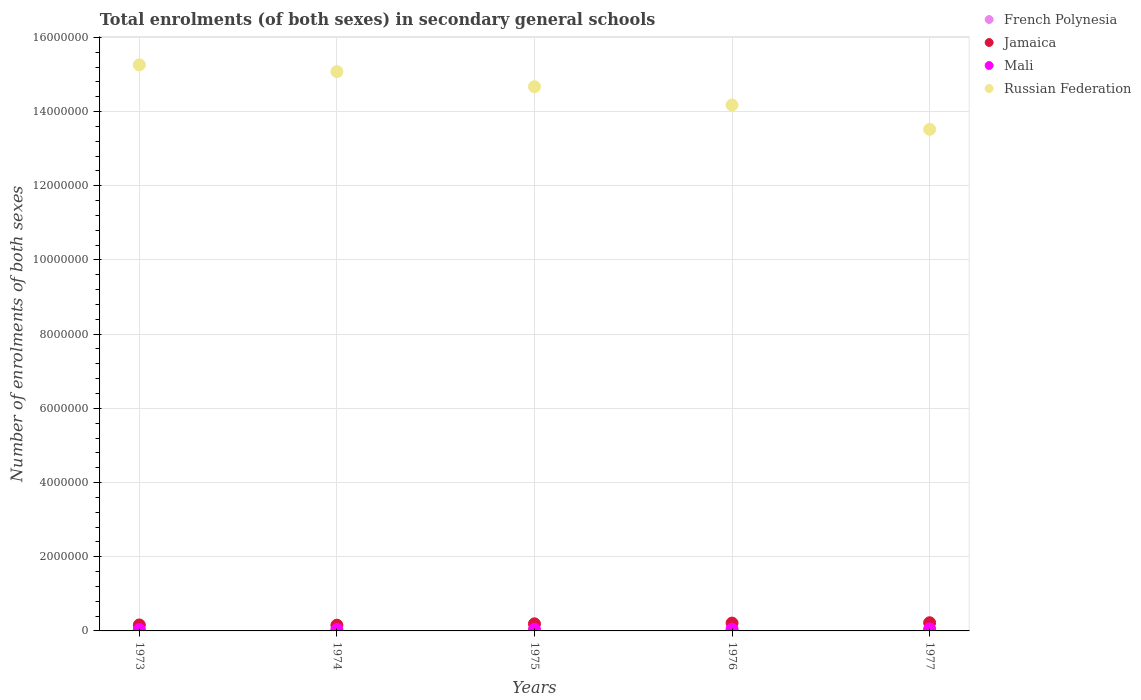What is the number of enrolments in secondary schools in Jamaica in 1976?
Ensure brevity in your answer.  2.11e+05. Across all years, what is the maximum number of enrolments in secondary schools in Mali?
Make the answer very short. 5.55e+04. Across all years, what is the minimum number of enrolments in secondary schools in Russian Federation?
Make the answer very short. 1.35e+07. What is the total number of enrolments in secondary schools in French Polynesia in the graph?
Your response must be concise. 3.49e+04. What is the difference between the number of enrolments in secondary schools in Russian Federation in 1973 and that in 1977?
Provide a succinct answer. 1.74e+06. What is the difference between the number of enrolments in secondary schools in Jamaica in 1974 and the number of enrolments in secondary schools in Russian Federation in 1977?
Your answer should be very brief. -1.34e+07. What is the average number of enrolments in secondary schools in Mali per year?
Ensure brevity in your answer.  4.39e+04. In the year 1973, what is the difference between the number of enrolments in secondary schools in Russian Federation and number of enrolments in secondary schools in French Polynesia?
Ensure brevity in your answer.  1.53e+07. In how many years, is the number of enrolments in secondary schools in French Polynesia greater than 1600000?
Give a very brief answer. 0. What is the ratio of the number of enrolments in secondary schools in French Polynesia in 1974 to that in 1976?
Your answer should be very brief. 0.91. Is the number of enrolments in secondary schools in Mali in 1973 less than that in 1976?
Your answer should be very brief. Yes. What is the difference between the highest and the second highest number of enrolments in secondary schools in Jamaica?
Your response must be concise. 9257. What is the difference between the highest and the lowest number of enrolments in secondary schools in Russian Federation?
Your answer should be very brief. 1.74e+06. In how many years, is the number of enrolments in secondary schools in Russian Federation greater than the average number of enrolments in secondary schools in Russian Federation taken over all years?
Give a very brief answer. 3. Is it the case that in every year, the sum of the number of enrolments in secondary schools in Russian Federation and number of enrolments in secondary schools in Mali  is greater than the sum of number of enrolments in secondary schools in Jamaica and number of enrolments in secondary schools in French Polynesia?
Offer a terse response. Yes. Is the number of enrolments in secondary schools in Mali strictly greater than the number of enrolments in secondary schools in Jamaica over the years?
Provide a succinct answer. No. How many dotlines are there?
Your answer should be very brief. 4. Are the values on the major ticks of Y-axis written in scientific E-notation?
Give a very brief answer. No. Does the graph contain any zero values?
Provide a succinct answer. No. What is the title of the graph?
Your response must be concise. Total enrolments (of both sexes) in secondary general schools. What is the label or title of the X-axis?
Offer a very short reply. Years. What is the label or title of the Y-axis?
Give a very brief answer. Number of enrolments of both sexes. What is the Number of enrolments of both sexes of French Polynesia in 1973?
Your answer should be very brief. 6239. What is the Number of enrolments of both sexes of Jamaica in 1973?
Offer a very short reply. 1.61e+05. What is the Number of enrolments of both sexes of Mali in 1973?
Offer a terse response. 3.46e+04. What is the Number of enrolments of both sexes in Russian Federation in 1973?
Offer a very short reply. 1.53e+07. What is the Number of enrolments of both sexes in French Polynesia in 1974?
Your answer should be very brief. 6597. What is the Number of enrolments of both sexes of Jamaica in 1974?
Ensure brevity in your answer.  1.55e+05. What is the Number of enrolments of both sexes of Mali in 1974?
Your response must be concise. 3.80e+04. What is the Number of enrolments of both sexes in Russian Federation in 1974?
Make the answer very short. 1.51e+07. What is the Number of enrolments of both sexes of French Polynesia in 1975?
Your answer should be very brief. 7046. What is the Number of enrolments of both sexes of Jamaica in 1975?
Give a very brief answer. 1.92e+05. What is the Number of enrolments of both sexes in Mali in 1975?
Make the answer very short. 4.27e+04. What is the Number of enrolments of both sexes in Russian Federation in 1975?
Keep it short and to the point. 1.47e+07. What is the Number of enrolments of both sexes in French Polynesia in 1976?
Make the answer very short. 7280. What is the Number of enrolments of both sexes of Jamaica in 1976?
Offer a very short reply. 2.11e+05. What is the Number of enrolments of both sexes of Mali in 1976?
Offer a terse response. 4.85e+04. What is the Number of enrolments of both sexes of Russian Federation in 1976?
Keep it short and to the point. 1.42e+07. What is the Number of enrolments of both sexes of French Polynesia in 1977?
Provide a succinct answer. 7727. What is the Number of enrolments of both sexes of Jamaica in 1977?
Offer a terse response. 2.21e+05. What is the Number of enrolments of both sexes in Mali in 1977?
Ensure brevity in your answer.  5.55e+04. What is the Number of enrolments of both sexes of Russian Federation in 1977?
Your response must be concise. 1.35e+07. Across all years, what is the maximum Number of enrolments of both sexes of French Polynesia?
Ensure brevity in your answer.  7727. Across all years, what is the maximum Number of enrolments of both sexes of Jamaica?
Your response must be concise. 2.21e+05. Across all years, what is the maximum Number of enrolments of both sexes of Mali?
Offer a very short reply. 5.55e+04. Across all years, what is the maximum Number of enrolments of both sexes of Russian Federation?
Ensure brevity in your answer.  1.53e+07. Across all years, what is the minimum Number of enrolments of both sexes of French Polynesia?
Provide a short and direct response. 6239. Across all years, what is the minimum Number of enrolments of both sexes of Jamaica?
Your answer should be compact. 1.55e+05. Across all years, what is the minimum Number of enrolments of both sexes in Mali?
Your answer should be compact. 3.46e+04. Across all years, what is the minimum Number of enrolments of both sexes of Russian Federation?
Your answer should be very brief. 1.35e+07. What is the total Number of enrolments of both sexes in French Polynesia in the graph?
Give a very brief answer. 3.49e+04. What is the total Number of enrolments of both sexes in Jamaica in the graph?
Offer a terse response. 9.39e+05. What is the total Number of enrolments of both sexes in Mali in the graph?
Offer a terse response. 2.19e+05. What is the total Number of enrolments of both sexes in Russian Federation in the graph?
Ensure brevity in your answer.  7.27e+07. What is the difference between the Number of enrolments of both sexes of French Polynesia in 1973 and that in 1974?
Provide a succinct answer. -358. What is the difference between the Number of enrolments of both sexes of Jamaica in 1973 and that in 1974?
Ensure brevity in your answer.  6427. What is the difference between the Number of enrolments of both sexes of Mali in 1973 and that in 1974?
Your response must be concise. -3370. What is the difference between the Number of enrolments of both sexes in Russian Federation in 1973 and that in 1974?
Your answer should be very brief. 1.83e+05. What is the difference between the Number of enrolments of both sexes of French Polynesia in 1973 and that in 1975?
Give a very brief answer. -807. What is the difference between the Number of enrolments of both sexes in Jamaica in 1973 and that in 1975?
Provide a short and direct response. -3.09e+04. What is the difference between the Number of enrolments of both sexes in Mali in 1973 and that in 1975?
Your response must be concise. -8040. What is the difference between the Number of enrolments of both sexes in Russian Federation in 1973 and that in 1975?
Offer a very short reply. 5.89e+05. What is the difference between the Number of enrolments of both sexes of French Polynesia in 1973 and that in 1976?
Your answer should be very brief. -1041. What is the difference between the Number of enrolments of both sexes of Jamaica in 1973 and that in 1976?
Your response must be concise. -5.03e+04. What is the difference between the Number of enrolments of both sexes in Mali in 1973 and that in 1976?
Ensure brevity in your answer.  -1.39e+04. What is the difference between the Number of enrolments of both sexes of Russian Federation in 1973 and that in 1976?
Your response must be concise. 1.08e+06. What is the difference between the Number of enrolments of both sexes in French Polynesia in 1973 and that in 1977?
Your answer should be very brief. -1488. What is the difference between the Number of enrolments of both sexes in Jamaica in 1973 and that in 1977?
Keep it short and to the point. -5.96e+04. What is the difference between the Number of enrolments of both sexes of Mali in 1973 and that in 1977?
Offer a very short reply. -2.09e+04. What is the difference between the Number of enrolments of both sexes of Russian Federation in 1973 and that in 1977?
Keep it short and to the point. 1.74e+06. What is the difference between the Number of enrolments of both sexes of French Polynesia in 1974 and that in 1975?
Provide a succinct answer. -449. What is the difference between the Number of enrolments of both sexes in Jamaica in 1974 and that in 1975?
Give a very brief answer. -3.73e+04. What is the difference between the Number of enrolments of both sexes in Mali in 1974 and that in 1975?
Keep it short and to the point. -4670. What is the difference between the Number of enrolments of both sexes of Russian Federation in 1974 and that in 1975?
Give a very brief answer. 4.06e+05. What is the difference between the Number of enrolments of both sexes in French Polynesia in 1974 and that in 1976?
Your answer should be compact. -683. What is the difference between the Number of enrolments of both sexes of Jamaica in 1974 and that in 1976?
Your answer should be compact. -5.68e+04. What is the difference between the Number of enrolments of both sexes of Mali in 1974 and that in 1976?
Make the answer very short. -1.05e+04. What is the difference between the Number of enrolments of both sexes of Russian Federation in 1974 and that in 1976?
Your answer should be very brief. 8.99e+05. What is the difference between the Number of enrolments of both sexes of French Polynesia in 1974 and that in 1977?
Give a very brief answer. -1130. What is the difference between the Number of enrolments of both sexes of Jamaica in 1974 and that in 1977?
Offer a very short reply. -6.60e+04. What is the difference between the Number of enrolments of both sexes in Mali in 1974 and that in 1977?
Give a very brief answer. -1.75e+04. What is the difference between the Number of enrolments of both sexes of Russian Federation in 1974 and that in 1977?
Make the answer very short. 1.56e+06. What is the difference between the Number of enrolments of both sexes of French Polynesia in 1975 and that in 1976?
Keep it short and to the point. -234. What is the difference between the Number of enrolments of both sexes of Jamaica in 1975 and that in 1976?
Give a very brief answer. -1.94e+04. What is the difference between the Number of enrolments of both sexes of Mali in 1975 and that in 1976?
Your response must be concise. -5820. What is the difference between the Number of enrolments of both sexes in Russian Federation in 1975 and that in 1976?
Offer a very short reply. 4.93e+05. What is the difference between the Number of enrolments of both sexes in French Polynesia in 1975 and that in 1977?
Your response must be concise. -681. What is the difference between the Number of enrolments of both sexes in Jamaica in 1975 and that in 1977?
Your answer should be very brief. -2.87e+04. What is the difference between the Number of enrolments of both sexes in Mali in 1975 and that in 1977?
Offer a terse response. -1.28e+04. What is the difference between the Number of enrolments of both sexes in Russian Federation in 1975 and that in 1977?
Give a very brief answer. 1.15e+06. What is the difference between the Number of enrolments of both sexes of French Polynesia in 1976 and that in 1977?
Give a very brief answer. -447. What is the difference between the Number of enrolments of both sexes of Jamaica in 1976 and that in 1977?
Provide a short and direct response. -9257. What is the difference between the Number of enrolments of both sexes in Mali in 1976 and that in 1977?
Keep it short and to the point. -6997. What is the difference between the Number of enrolments of both sexes of Russian Federation in 1976 and that in 1977?
Your answer should be very brief. 6.56e+05. What is the difference between the Number of enrolments of both sexes in French Polynesia in 1973 and the Number of enrolments of both sexes in Jamaica in 1974?
Ensure brevity in your answer.  -1.48e+05. What is the difference between the Number of enrolments of both sexes in French Polynesia in 1973 and the Number of enrolments of both sexes in Mali in 1974?
Your answer should be compact. -3.18e+04. What is the difference between the Number of enrolments of both sexes in French Polynesia in 1973 and the Number of enrolments of both sexes in Russian Federation in 1974?
Give a very brief answer. -1.51e+07. What is the difference between the Number of enrolments of both sexes in Jamaica in 1973 and the Number of enrolments of both sexes in Mali in 1974?
Give a very brief answer. 1.23e+05. What is the difference between the Number of enrolments of both sexes in Jamaica in 1973 and the Number of enrolments of both sexes in Russian Federation in 1974?
Your response must be concise. -1.49e+07. What is the difference between the Number of enrolments of both sexes of Mali in 1973 and the Number of enrolments of both sexes of Russian Federation in 1974?
Your answer should be compact. -1.50e+07. What is the difference between the Number of enrolments of both sexes of French Polynesia in 1973 and the Number of enrolments of both sexes of Jamaica in 1975?
Provide a short and direct response. -1.86e+05. What is the difference between the Number of enrolments of both sexes in French Polynesia in 1973 and the Number of enrolments of both sexes in Mali in 1975?
Your answer should be compact. -3.64e+04. What is the difference between the Number of enrolments of both sexes of French Polynesia in 1973 and the Number of enrolments of both sexes of Russian Federation in 1975?
Give a very brief answer. -1.47e+07. What is the difference between the Number of enrolments of both sexes of Jamaica in 1973 and the Number of enrolments of both sexes of Mali in 1975?
Offer a very short reply. 1.18e+05. What is the difference between the Number of enrolments of both sexes in Jamaica in 1973 and the Number of enrolments of both sexes in Russian Federation in 1975?
Your answer should be very brief. -1.45e+07. What is the difference between the Number of enrolments of both sexes in Mali in 1973 and the Number of enrolments of both sexes in Russian Federation in 1975?
Your response must be concise. -1.46e+07. What is the difference between the Number of enrolments of both sexes in French Polynesia in 1973 and the Number of enrolments of both sexes in Jamaica in 1976?
Provide a succinct answer. -2.05e+05. What is the difference between the Number of enrolments of both sexes of French Polynesia in 1973 and the Number of enrolments of both sexes of Mali in 1976?
Your answer should be compact. -4.22e+04. What is the difference between the Number of enrolments of both sexes of French Polynesia in 1973 and the Number of enrolments of both sexes of Russian Federation in 1976?
Make the answer very short. -1.42e+07. What is the difference between the Number of enrolments of both sexes of Jamaica in 1973 and the Number of enrolments of both sexes of Mali in 1976?
Give a very brief answer. 1.12e+05. What is the difference between the Number of enrolments of both sexes of Jamaica in 1973 and the Number of enrolments of both sexes of Russian Federation in 1976?
Provide a short and direct response. -1.40e+07. What is the difference between the Number of enrolments of both sexes of Mali in 1973 and the Number of enrolments of both sexes of Russian Federation in 1976?
Your answer should be very brief. -1.41e+07. What is the difference between the Number of enrolments of both sexes of French Polynesia in 1973 and the Number of enrolments of both sexes of Jamaica in 1977?
Ensure brevity in your answer.  -2.14e+05. What is the difference between the Number of enrolments of both sexes in French Polynesia in 1973 and the Number of enrolments of both sexes in Mali in 1977?
Offer a terse response. -4.92e+04. What is the difference between the Number of enrolments of both sexes in French Polynesia in 1973 and the Number of enrolments of both sexes in Russian Federation in 1977?
Keep it short and to the point. -1.35e+07. What is the difference between the Number of enrolments of both sexes of Jamaica in 1973 and the Number of enrolments of both sexes of Mali in 1977?
Ensure brevity in your answer.  1.05e+05. What is the difference between the Number of enrolments of both sexes in Jamaica in 1973 and the Number of enrolments of both sexes in Russian Federation in 1977?
Make the answer very short. -1.34e+07. What is the difference between the Number of enrolments of both sexes of Mali in 1973 and the Number of enrolments of both sexes of Russian Federation in 1977?
Keep it short and to the point. -1.35e+07. What is the difference between the Number of enrolments of both sexes in French Polynesia in 1974 and the Number of enrolments of both sexes in Jamaica in 1975?
Your answer should be compact. -1.85e+05. What is the difference between the Number of enrolments of both sexes in French Polynesia in 1974 and the Number of enrolments of both sexes in Mali in 1975?
Give a very brief answer. -3.61e+04. What is the difference between the Number of enrolments of both sexes in French Polynesia in 1974 and the Number of enrolments of both sexes in Russian Federation in 1975?
Give a very brief answer. -1.47e+07. What is the difference between the Number of enrolments of both sexes of Jamaica in 1974 and the Number of enrolments of both sexes of Mali in 1975?
Your response must be concise. 1.12e+05. What is the difference between the Number of enrolments of both sexes in Jamaica in 1974 and the Number of enrolments of both sexes in Russian Federation in 1975?
Your answer should be compact. -1.45e+07. What is the difference between the Number of enrolments of both sexes of Mali in 1974 and the Number of enrolments of both sexes of Russian Federation in 1975?
Your answer should be very brief. -1.46e+07. What is the difference between the Number of enrolments of both sexes of French Polynesia in 1974 and the Number of enrolments of both sexes of Jamaica in 1976?
Provide a succinct answer. -2.05e+05. What is the difference between the Number of enrolments of both sexes in French Polynesia in 1974 and the Number of enrolments of both sexes in Mali in 1976?
Offer a terse response. -4.19e+04. What is the difference between the Number of enrolments of both sexes in French Polynesia in 1974 and the Number of enrolments of both sexes in Russian Federation in 1976?
Ensure brevity in your answer.  -1.42e+07. What is the difference between the Number of enrolments of both sexes in Jamaica in 1974 and the Number of enrolments of both sexes in Mali in 1976?
Offer a terse response. 1.06e+05. What is the difference between the Number of enrolments of both sexes of Jamaica in 1974 and the Number of enrolments of both sexes of Russian Federation in 1976?
Make the answer very short. -1.40e+07. What is the difference between the Number of enrolments of both sexes in Mali in 1974 and the Number of enrolments of both sexes in Russian Federation in 1976?
Your answer should be compact. -1.41e+07. What is the difference between the Number of enrolments of both sexes in French Polynesia in 1974 and the Number of enrolments of both sexes in Jamaica in 1977?
Give a very brief answer. -2.14e+05. What is the difference between the Number of enrolments of both sexes of French Polynesia in 1974 and the Number of enrolments of both sexes of Mali in 1977?
Make the answer very short. -4.89e+04. What is the difference between the Number of enrolments of both sexes in French Polynesia in 1974 and the Number of enrolments of both sexes in Russian Federation in 1977?
Provide a succinct answer. -1.35e+07. What is the difference between the Number of enrolments of both sexes of Jamaica in 1974 and the Number of enrolments of both sexes of Mali in 1977?
Make the answer very short. 9.91e+04. What is the difference between the Number of enrolments of both sexes in Jamaica in 1974 and the Number of enrolments of both sexes in Russian Federation in 1977?
Provide a succinct answer. -1.34e+07. What is the difference between the Number of enrolments of both sexes in Mali in 1974 and the Number of enrolments of both sexes in Russian Federation in 1977?
Offer a terse response. -1.35e+07. What is the difference between the Number of enrolments of both sexes in French Polynesia in 1975 and the Number of enrolments of both sexes in Jamaica in 1976?
Keep it short and to the point. -2.04e+05. What is the difference between the Number of enrolments of both sexes in French Polynesia in 1975 and the Number of enrolments of both sexes in Mali in 1976?
Your answer should be very brief. -4.14e+04. What is the difference between the Number of enrolments of both sexes in French Polynesia in 1975 and the Number of enrolments of both sexes in Russian Federation in 1976?
Your answer should be compact. -1.42e+07. What is the difference between the Number of enrolments of both sexes in Jamaica in 1975 and the Number of enrolments of both sexes in Mali in 1976?
Provide a succinct answer. 1.43e+05. What is the difference between the Number of enrolments of both sexes in Jamaica in 1975 and the Number of enrolments of both sexes in Russian Federation in 1976?
Offer a terse response. -1.40e+07. What is the difference between the Number of enrolments of both sexes of Mali in 1975 and the Number of enrolments of both sexes of Russian Federation in 1976?
Ensure brevity in your answer.  -1.41e+07. What is the difference between the Number of enrolments of both sexes of French Polynesia in 1975 and the Number of enrolments of both sexes of Jamaica in 1977?
Your answer should be very brief. -2.14e+05. What is the difference between the Number of enrolments of both sexes of French Polynesia in 1975 and the Number of enrolments of both sexes of Mali in 1977?
Offer a very short reply. -4.84e+04. What is the difference between the Number of enrolments of both sexes in French Polynesia in 1975 and the Number of enrolments of both sexes in Russian Federation in 1977?
Your response must be concise. -1.35e+07. What is the difference between the Number of enrolments of both sexes in Jamaica in 1975 and the Number of enrolments of both sexes in Mali in 1977?
Provide a succinct answer. 1.36e+05. What is the difference between the Number of enrolments of both sexes in Jamaica in 1975 and the Number of enrolments of both sexes in Russian Federation in 1977?
Offer a very short reply. -1.33e+07. What is the difference between the Number of enrolments of both sexes in Mali in 1975 and the Number of enrolments of both sexes in Russian Federation in 1977?
Offer a very short reply. -1.35e+07. What is the difference between the Number of enrolments of both sexes in French Polynesia in 1976 and the Number of enrolments of both sexes in Jamaica in 1977?
Offer a terse response. -2.13e+05. What is the difference between the Number of enrolments of both sexes in French Polynesia in 1976 and the Number of enrolments of both sexes in Mali in 1977?
Keep it short and to the point. -4.82e+04. What is the difference between the Number of enrolments of both sexes in French Polynesia in 1976 and the Number of enrolments of both sexes in Russian Federation in 1977?
Give a very brief answer. -1.35e+07. What is the difference between the Number of enrolments of both sexes in Jamaica in 1976 and the Number of enrolments of both sexes in Mali in 1977?
Make the answer very short. 1.56e+05. What is the difference between the Number of enrolments of both sexes in Jamaica in 1976 and the Number of enrolments of both sexes in Russian Federation in 1977?
Your answer should be compact. -1.33e+07. What is the difference between the Number of enrolments of both sexes of Mali in 1976 and the Number of enrolments of both sexes of Russian Federation in 1977?
Provide a succinct answer. -1.35e+07. What is the average Number of enrolments of both sexes of French Polynesia per year?
Provide a succinct answer. 6977.8. What is the average Number of enrolments of both sexes in Jamaica per year?
Your response must be concise. 1.88e+05. What is the average Number of enrolments of both sexes in Mali per year?
Give a very brief answer. 4.39e+04. What is the average Number of enrolments of both sexes of Russian Federation per year?
Keep it short and to the point. 1.45e+07. In the year 1973, what is the difference between the Number of enrolments of both sexes of French Polynesia and Number of enrolments of both sexes of Jamaica?
Your answer should be compact. -1.55e+05. In the year 1973, what is the difference between the Number of enrolments of both sexes in French Polynesia and Number of enrolments of both sexes in Mali?
Provide a short and direct response. -2.84e+04. In the year 1973, what is the difference between the Number of enrolments of both sexes in French Polynesia and Number of enrolments of both sexes in Russian Federation?
Make the answer very short. -1.53e+07. In the year 1973, what is the difference between the Number of enrolments of both sexes in Jamaica and Number of enrolments of both sexes in Mali?
Offer a very short reply. 1.26e+05. In the year 1973, what is the difference between the Number of enrolments of both sexes of Jamaica and Number of enrolments of both sexes of Russian Federation?
Offer a terse response. -1.51e+07. In the year 1973, what is the difference between the Number of enrolments of both sexes of Mali and Number of enrolments of both sexes of Russian Federation?
Offer a terse response. -1.52e+07. In the year 1974, what is the difference between the Number of enrolments of both sexes of French Polynesia and Number of enrolments of both sexes of Jamaica?
Keep it short and to the point. -1.48e+05. In the year 1974, what is the difference between the Number of enrolments of both sexes in French Polynesia and Number of enrolments of both sexes in Mali?
Keep it short and to the point. -3.14e+04. In the year 1974, what is the difference between the Number of enrolments of both sexes of French Polynesia and Number of enrolments of both sexes of Russian Federation?
Make the answer very short. -1.51e+07. In the year 1974, what is the difference between the Number of enrolments of both sexes in Jamaica and Number of enrolments of both sexes in Mali?
Give a very brief answer. 1.17e+05. In the year 1974, what is the difference between the Number of enrolments of both sexes in Jamaica and Number of enrolments of both sexes in Russian Federation?
Give a very brief answer. -1.49e+07. In the year 1974, what is the difference between the Number of enrolments of both sexes of Mali and Number of enrolments of both sexes of Russian Federation?
Offer a very short reply. -1.50e+07. In the year 1975, what is the difference between the Number of enrolments of both sexes in French Polynesia and Number of enrolments of both sexes in Jamaica?
Provide a short and direct response. -1.85e+05. In the year 1975, what is the difference between the Number of enrolments of both sexes in French Polynesia and Number of enrolments of both sexes in Mali?
Offer a terse response. -3.56e+04. In the year 1975, what is the difference between the Number of enrolments of both sexes in French Polynesia and Number of enrolments of both sexes in Russian Federation?
Keep it short and to the point. -1.47e+07. In the year 1975, what is the difference between the Number of enrolments of both sexes of Jamaica and Number of enrolments of both sexes of Mali?
Your response must be concise. 1.49e+05. In the year 1975, what is the difference between the Number of enrolments of both sexes of Jamaica and Number of enrolments of both sexes of Russian Federation?
Your response must be concise. -1.45e+07. In the year 1975, what is the difference between the Number of enrolments of both sexes in Mali and Number of enrolments of both sexes in Russian Federation?
Your answer should be very brief. -1.46e+07. In the year 1976, what is the difference between the Number of enrolments of both sexes of French Polynesia and Number of enrolments of both sexes of Jamaica?
Offer a very short reply. -2.04e+05. In the year 1976, what is the difference between the Number of enrolments of both sexes of French Polynesia and Number of enrolments of both sexes of Mali?
Provide a short and direct response. -4.12e+04. In the year 1976, what is the difference between the Number of enrolments of both sexes in French Polynesia and Number of enrolments of both sexes in Russian Federation?
Your answer should be compact. -1.42e+07. In the year 1976, what is the difference between the Number of enrolments of both sexes in Jamaica and Number of enrolments of both sexes in Mali?
Your answer should be very brief. 1.63e+05. In the year 1976, what is the difference between the Number of enrolments of both sexes of Jamaica and Number of enrolments of both sexes of Russian Federation?
Your response must be concise. -1.40e+07. In the year 1976, what is the difference between the Number of enrolments of both sexes of Mali and Number of enrolments of both sexes of Russian Federation?
Ensure brevity in your answer.  -1.41e+07. In the year 1977, what is the difference between the Number of enrolments of both sexes of French Polynesia and Number of enrolments of both sexes of Jamaica?
Keep it short and to the point. -2.13e+05. In the year 1977, what is the difference between the Number of enrolments of both sexes of French Polynesia and Number of enrolments of both sexes of Mali?
Keep it short and to the point. -4.78e+04. In the year 1977, what is the difference between the Number of enrolments of both sexes of French Polynesia and Number of enrolments of both sexes of Russian Federation?
Offer a very short reply. -1.35e+07. In the year 1977, what is the difference between the Number of enrolments of both sexes in Jamaica and Number of enrolments of both sexes in Mali?
Keep it short and to the point. 1.65e+05. In the year 1977, what is the difference between the Number of enrolments of both sexes of Jamaica and Number of enrolments of both sexes of Russian Federation?
Make the answer very short. -1.33e+07. In the year 1977, what is the difference between the Number of enrolments of both sexes in Mali and Number of enrolments of both sexes in Russian Federation?
Offer a very short reply. -1.35e+07. What is the ratio of the Number of enrolments of both sexes of French Polynesia in 1973 to that in 1974?
Offer a terse response. 0.95. What is the ratio of the Number of enrolments of both sexes in Jamaica in 1973 to that in 1974?
Your answer should be very brief. 1.04. What is the ratio of the Number of enrolments of both sexes in Mali in 1973 to that in 1974?
Provide a short and direct response. 0.91. What is the ratio of the Number of enrolments of both sexes in Russian Federation in 1973 to that in 1974?
Your answer should be very brief. 1.01. What is the ratio of the Number of enrolments of both sexes in French Polynesia in 1973 to that in 1975?
Ensure brevity in your answer.  0.89. What is the ratio of the Number of enrolments of both sexes in Jamaica in 1973 to that in 1975?
Ensure brevity in your answer.  0.84. What is the ratio of the Number of enrolments of both sexes of Mali in 1973 to that in 1975?
Your answer should be very brief. 0.81. What is the ratio of the Number of enrolments of both sexes in Russian Federation in 1973 to that in 1975?
Make the answer very short. 1.04. What is the ratio of the Number of enrolments of both sexes of French Polynesia in 1973 to that in 1976?
Make the answer very short. 0.86. What is the ratio of the Number of enrolments of both sexes in Jamaica in 1973 to that in 1976?
Ensure brevity in your answer.  0.76. What is the ratio of the Number of enrolments of both sexes in Mali in 1973 to that in 1976?
Give a very brief answer. 0.71. What is the ratio of the Number of enrolments of both sexes in Russian Federation in 1973 to that in 1976?
Give a very brief answer. 1.08. What is the ratio of the Number of enrolments of both sexes in French Polynesia in 1973 to that in 1977?
Make the answer very short. 0.81. What is the ratio of the Number of enrolments of both sexes of Jamaica in 1973 to that in 1977?
Your response must be concise. 0.73. What is the ratio of the Number of enrolments of both sexes of Mali in 1973 to that in 1977?
Your response must be concise. 0.62. What is the ratio of the Number of enrolments of both sexes in Russian Federation in 1973 to that in 1977?
Keep it short and to the point. 1.13. What is the ratio of the Number of enrolments of both sexes in French Polynesia in 1974 to that in 1975?
Give a very brief answer. 0.94. What is the ratio of the Number of enrolments of both sexes of Jamaica in 1974 to that in 1975?
Give a very brief answer. 0.81. What is the ratio of the Number of enrolments of both sexes in Mali in 1974 to that in 1975?
Offer a very short reply. 0.89. What is the ratio of the Number of enrolments of both sexes of Russian Federation in 1974 to that in 1975?
Provide a short and direct response. 1.03. What is the ratio of the Number of enrolments of both sexes of French Polynesia in 1974 to that in 1976?
Provide a succinct answer. 0.91. What is the ratio of the Number of enrolments of both sexes in Jamaica in 1974 to that in 1976?
Your response must be concise. 0.73. What is the ratio of the Number of enrolments of both sexes of Mali in 1974 to that in 1976?
Provide a short and direct response. 0.78. What is the ratio of the Number of enrolments of both sexes in Russian Federation in 1974 to that in 1976?
Offer a terse response. 1.06. What is the ratio of the Number of enrolments of both sexes in French Polynesia in 1974 to that in 1977?
Give a very brief answer. 0.85. What is the ratio of the Number of enrolments of both sexes of Jamaica in 1974 to that in 1977?
Give a very brief answer. 0.7. What is the ratio of the Number of enrolments of both sexes in Mali in 1974 to that in 1977?
Provide a succinct answer. 0.68. What is the ratio of the Number of enrolments of both sexes in Russian Federation in 1974 to that in 1977?
Keep it short and to the point. 1.11. What is the ratio of the Number of enrolments of both sexes of French Polynesia in 1975 to that in 1976?
Offer a very short reply. 0.97. What is the ratio of the Number of enrolments of both sexes of Jamaica in 1975 to that in 1976?
Provide a succinct answer. 0.91. What is the ratio of the Number of enrolments of both sexes in Russian Federation in 1975 to that in 1976?
Provide a succinct answer. 1.03. What is the ratio of the Number of enrolments of both sexes of French Polynesia in 1975 to that in 1977?
Your answer should be very brief. 0.91. What is the ratio of the Number of enrolments of both sexes of Jamaica in 1975 to that in 1977?
Your answer should be compact. 0.87. What is the ratio of the Number of enrolments of both sexes of Mali in 1975 to that in 1977?
Keep it short and to the point. 0.77. What is the ratio of the Number of enrolments of both sexes of Russian Federation in 1975 to that in 1977?
Keep it short and to the point. 1.08. What is the ratio of the Number of enrolments of both sexes in French Polynesia in 1976 to that in 1977?
Provide a short and direct response. 0.94. What is the ratio of the Number of enrolments of both sexes of Jamaica in 1976 to that in 1977?
Make the answer very short. 0.96. What is the ratio of the Number of enrolments of both sexes of Mali in 1976 to that in 1977?
Make the answer very short. 0.87. What is the ratio of the Number of enrolments of both sexes of Russian Federation in 1976 to that in 1977?
Offer a very short reply. 1.05. What is the difference between the highest and the second highest Number of enrolments of both sexes of French Polynesia?
Ensure brevity in your answer.  447. What is the difference between the highest and the second highest Number of enrolments of both sexes of Jamaica?
Your answer should be very brief. 9257. What is the difference between the highest and the second highest Number of enrolments of both sexes in Mali?
Your answer should be very brief. 6997. What is the difference between the highest and the second highest Number of enrolments of both sexes of Russian Federation?
Your answer should be compact. 1.83e+05. What is the difference between the highest and the lowest Number of enrolments of both sexes of French Polynesia?
Give a very brief answer. 1488. What is the difference between the highest and the lowest Number of enrolments of both sexes in Jamaica?
Provide a short and direct response. 6.60e+04. What is the difference between the highest and the lowest Number of enrolments of both sexes of Mali?
Your answer should be very brief. 2.09e+04. What is the difference between the highest and the lowest Number of enrolments of both sexes in Russian Federation?
Offer a very short reply. 1.74e+06. 